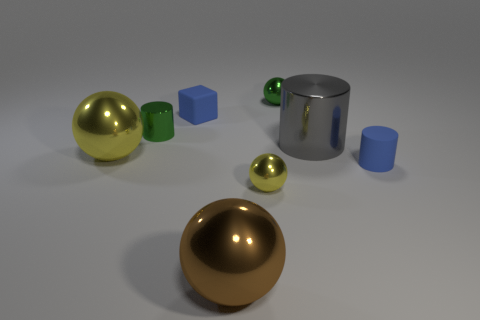Does the rubber cylinder have the same color as the rubber object on the left side of the gray object?
Offer a very short reply. Yes. How many tiny blue matte objects are behind the tiny green metal cylinder and to the right of the green shiny ball?
Give a very brief answer. 0. There is a big brown shiny thing that is in front of the big shiny cylinder; what shape is it?
Ensure brevity in your answer.  Sphere. What number of large cylinders are made of the same material as the small blue block?
Give a very brief answer. 0. Does the small yellow shiny object have the same shape as the large thing that is in front of the blue rubber cylinder?
Provide a succinct answer. Yes. There is a sphere behind the blue object behind the big gray cylinder; is there a green cylinder that is in front of it?
Offer a very short reply. Yes. There is a yellow shiny sphere that is left of the blue matte cube; how big is it?
Ensure brevity in your answer.  Large. What material is the blue cylinder that is the same size as the green metal cylinder?
Your answer should be compact. Rubber. Is the gray object the same shape as the large brown object?
Give a very brief answer. No. How many things are shiny cylinders or blue objects in front of the green metallic cylinder?
Your response must be concise. 3. 